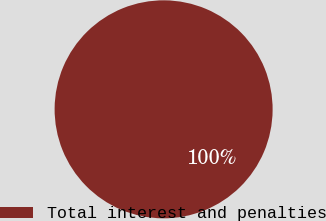Convert chart to OTSL. <chart><loc_0><loc_0><loc_500><loc_500><pie_chart><fcel>Total interest and penalties<nl><fcel>100.0%<nl></chart> 